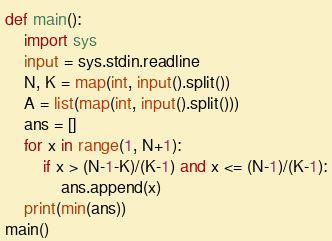<code> <loc_0><loc_0><loc_500><loc_500><_Python_>def main():
    import sys
    input = sys.stdin.readline
    N, K = map(int, input().split())
    A = list(map(int, input().split()))
    ans = []
    for x in range(1, N+1):
        if x > (N-1-K)/(K-1) and x <= (N-1)/(K-1):
            ans.append(x)
    print(min(ans))
main()</code> 